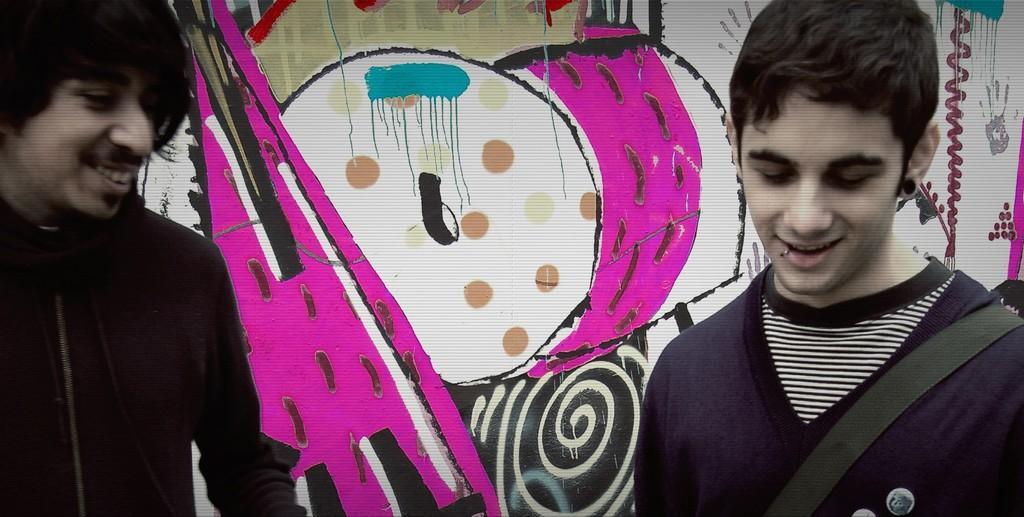In one or two sentences, can you explain what this image depicts? In this image I can see two persons they are smiling in the background I can see the color full wall and on the wall I can see a colorful painting. 